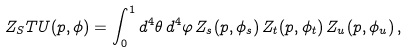<formula> <loc_0><loc_0><loc_500><loc_500>Z _ { S } T U ( p , \phi ) = \int _ { 0 } ^ { 1 } d ^ { 4 } \theta \, d ^ { 4 } \varphi \, Z _ { s } ( p , \phi _ { s } ) \, Z _ { t } ( p , \phi _ { t } ) \, Z _ { u } ( p , \phi _ { u } ) \, ,</formula> 